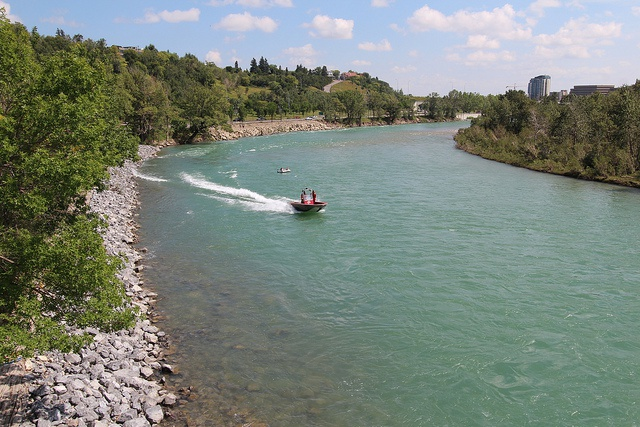Describe the objects in this image and their specific colors. I can see boat in darkgray, black, gray, and lightpink tones, boat in darkgray, gray, and lightgray tones, people in darkgray, gray, black, and maroon tones, and people in darkgray, maroon, black, gray, and brown tones in this image. 